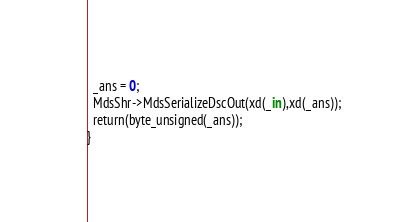<code> <loc_0><loc_0><loc_500><loc_500><_SML_>  _ans = 0;
  MdsShr->MdsSerializeDscOut(xd(_in),xd(_ans));
  return(byte_unsigned(_ans));
}
</code> 